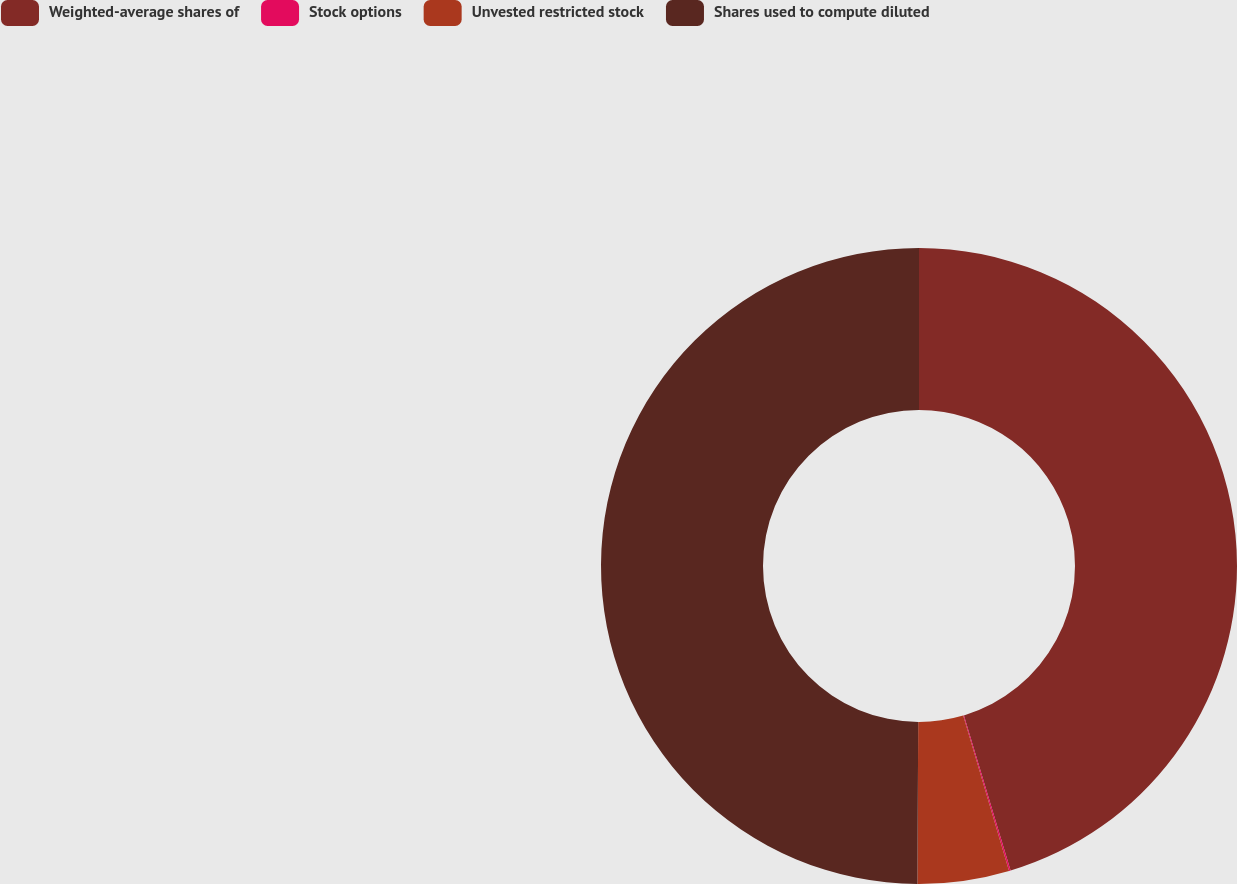Convert chart. <chart><loc_0><loc_0><loc_500><loc_500><pie_chart><fcel>Weighted-average shares of<fcel>Stock options<fcel>Unvested restricted stock<fcel>Shares used to compute diluted<nl><fcel>45.35%<fcel>0.08%<fcel>4.65%<fcel>49.92%<nl></chart> 